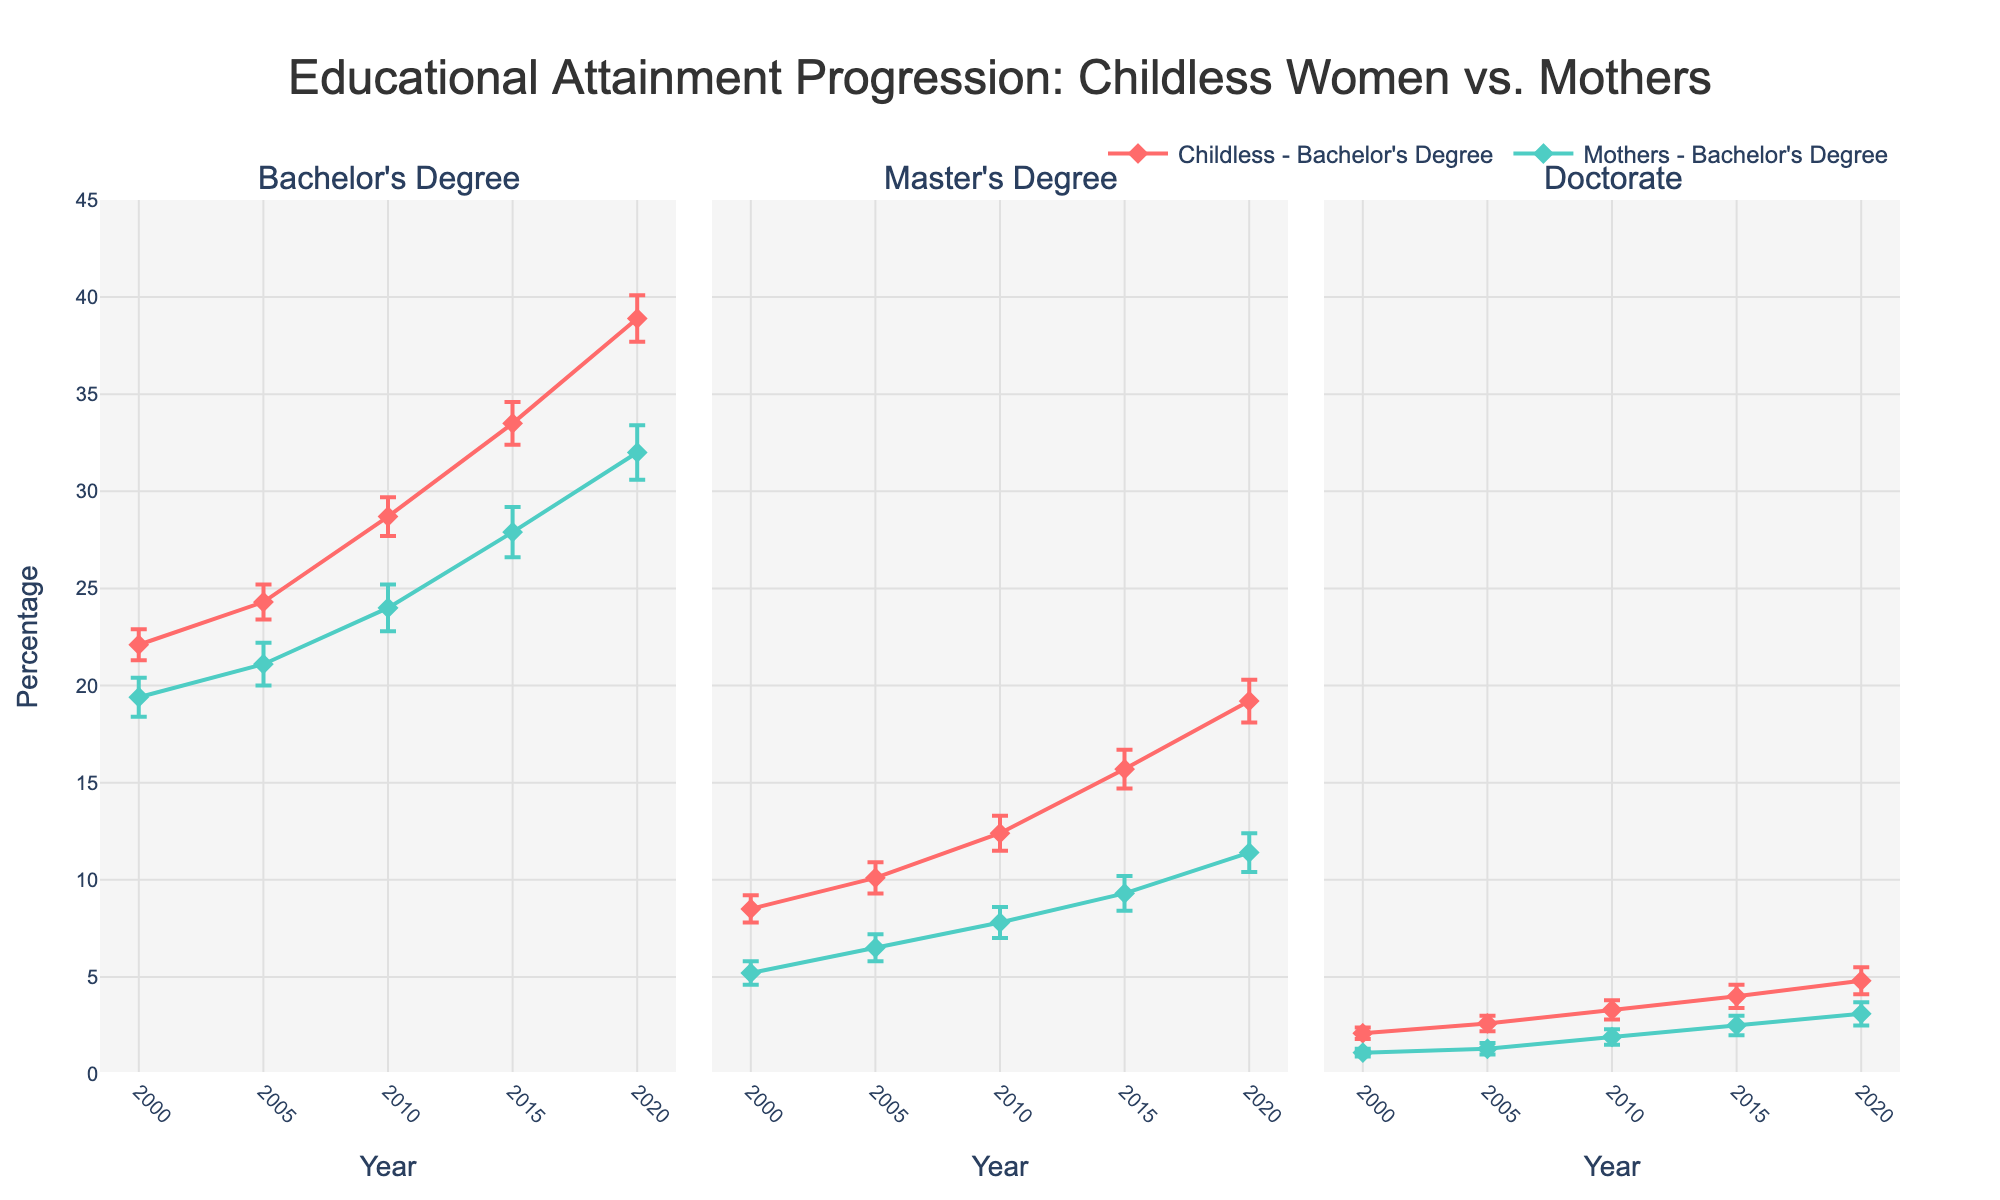How many educational levels are analyzed in the figure? The subplot titles indicate the educational levels being analyzed. Three educational levels are mentioned: Bachelor's Degree, Master's Degree, and Doctorate.
Answer: 3 Which group had a higher percentage of Master's Degrees in 2010: Childless women or mothers? Looking at the Master's Degree subplot for the year 2010, the green line (childless) indicates a higher percentage than the other line. Childless women had 12.4% and mothers had 7.8%.
Answer: Childless women What is the trend for the percentage of Childless women with a Doctorate from 2000 to 2020? By observing the line plot for Doctorate, you notice that the percentage of Childless women increases over the years. It starts from 2.1% in 2000 and rises to 4.8% in 2020.
Answer: Increases Compare the Bachelor’s degree percentage in 2005 for mothers and childless women. Which group had a higher percentage, and by how much? In the Bachelor's Degree subplot for 2005, the pink line (childless) is higher than the other line. Childless women had 24.3% and mothers had 21.1%. The difference is 24.3 - 21.1, which equals 3.2%.
Answer: Childless women, by 3.2% What can be inferred about the error margin for Master's Degrees in 2015 for mothers? Observing the error bars for the Master's Degree subplot in 2015, you notice the error margin is represented by the vertical extension of the blue line. It appears smaller indicating a lower standard error compared to the Childless women line. The exact standard error is 0.9%.
Answer: 0.9% How has the percentage of mothers with a Bachelor's degree changed from 2000 to 2020? By examining the Bachelor's Degree subplot for the mothers' line (blue), you see an upward trend from 19.4% in 2000 to 32.0% in 2020, indicating an increase.
Answer: Increased In which year did childless women have the largest percentage increase for Doctorate degrees, and what was the increase? (Between consecutive years) By comparing the y-values for Childless women in the Doctorate subplot across the given years, the largest increase occurred from 2015 (4.0%) to 2020 (4.8%). The increase is 4.8% - 4.0%, which equals 0.8%.
Answer: 2020, 0.8% What is the largest gap in Bachelor's degree attainment between childless women and mothers across all years? By checking the different years in the Bachelor's Degree subplot, the largest gap appears to be in 2020. Childless women had 38.9% and mothers had 32.0%. The difference is 38.9 - 32.0, which equals 6.9%.
Answer: 6.9% What is the average percentage of Bachelor's degrees attained by mothers over the period 2000 to 2020? To find the average, add the percentages for mothers in Bachelor's degree subplot (19.4, 21.1, 24.0, 27.9, 32.0) and then divide by the number of data points: (19.4 + 21.1 + 24.0 + 27.9 + 32.0) / 5 = 124.4 / 5 = 24.9%.
Answer: 24.9% How do the standard errors compare for Doctorate degrees between Childless women and mothers in 2005? By examining the error bars for Doctorate subplot in 2005, the pink and blue lines indicate the error margins. For Childless women, the standard error is 0.4% and for mothers, it is 0.3%.
Answer: Childless women have a higher standard error 